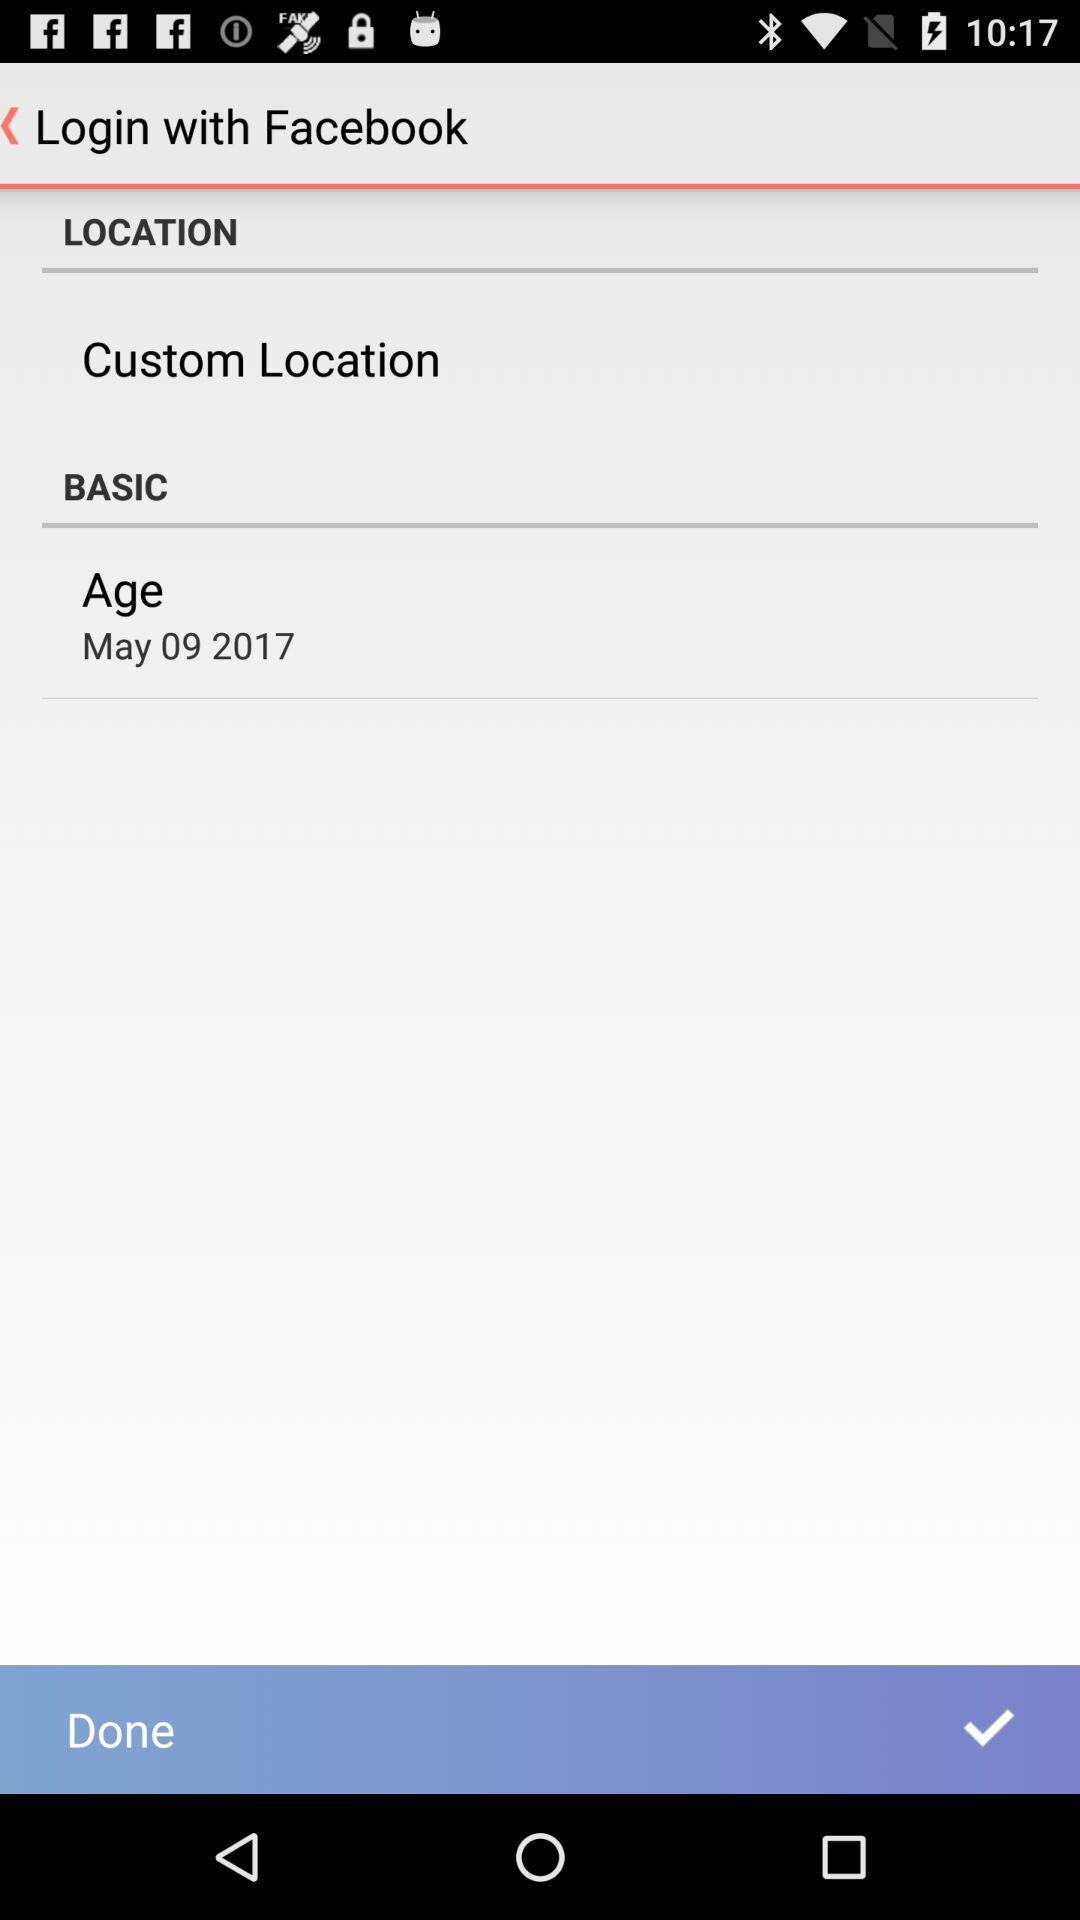What account is mentioned for login? The account that can be used to login is "Facebook". 